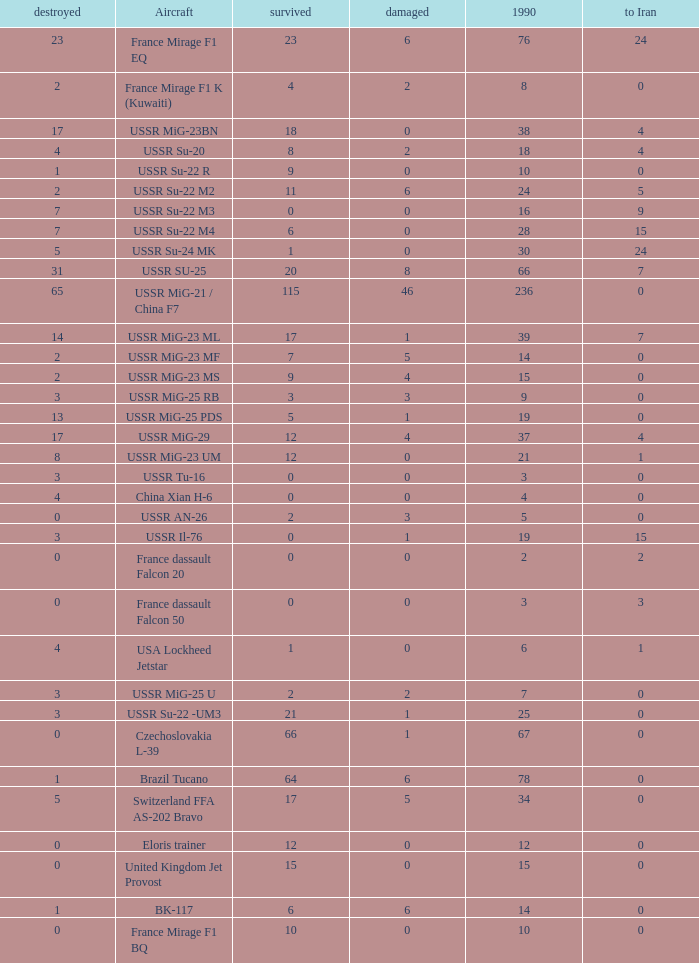If there were 14 in 1990 and 6 survived how many were destroyed? 1.0. 